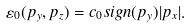<formula> <loc_0><loc_0><loc_500><loc_500>\varepsilon _ { 0 } ( p _ { y } , p _ { z } ) = c _ { 0 } s i g n ( p _ { y } ) | p _ { x } | .</formula> 